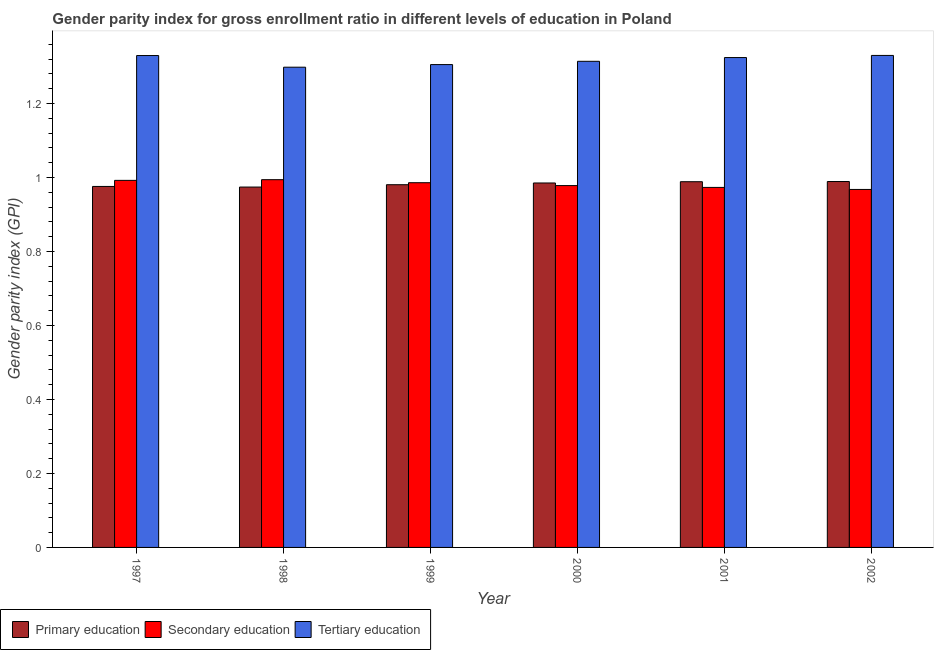Are the number of bars per tick equal to the number of legend labels?
Keep it short and to the point. Yes. Are the number of bars on each tick of the X-axis equal?
Provide a short and direct response. Yes. How many bars are there on the 1st tick from the left?
Provide a succinct answer. 3. What is the label of the 6th group of bars from the left?
Keep it short and to the point. 2002. In how many cases, is the number of bars for a given year not equal to the number of legend labels?
Ensure brevity in your answer.  0. What is the gender parity index in tertiary education in 2000?
Provide a short and direct response. 1.31. Across all years, what is the maximum gender parity index in primary education?
Provide a succinct answer. 0.99. Across all years, what is the minimum gender parity index in primary education?
Your answer should be compact. 0.97. What is the total gender parity index in primary education in the graph?
Ensure brevity in your answer.  5.89. What is the difference between the gender parity index in secondary education in 1997 and that in 2000?
Your answer should be compact. 0.01. What is the difference between the gender parity index in tertiary education in 1999 and the gender parity index in secondary education in 1997?
Offer a terse response. -0.02. What is the average gender parity index in tertiary education per year?
Keep it short and to the point. 1.32. In the year 1999, what is the difference between the gender parity index in tertiary education and gender parity index in primary education?
Your response must be concise. 0. What is the ratio of the gender parity index in secondary education in 1997 to that in 1998?
Offer a very short reply. 1. What is the difference between the highest and the second highest gender parity index in tertiary education?
Offer a terse response. 0. What is the difference between the highest and the lowest gender parity index in primary education?
Keep it short and to the point. 0.01. What does the 3rd bar from the left in 2001 represents?
Provide a short and direct response. Tertiary education. How many bars are there?
Keep it short and to the point. 18. How many years are there in the graph?
Ensure brevity in your answer.  6. Does the graph contain grids?
Provide a succinct answer. No. How are the legend labels stacked?
Your answer should be compact. Horizontal. What is the title of the graph?
Your answer should be very brief. Gender parity index for gross enrollment ratio in different levels of education in Poland. What is the label or title of the X-axis?
Your answer should be very brief. Year. What is the label or title of the Y-axis?
Offer a terse response. Gender parity index (GPI). What is the Gender parity index (GPI) of Primary education in 1997?
Provide a short and direct response. 0.98. What is the Gender parity index (GPI) of Tertiary education in 1997?
Your answer should be very brief. 1.33. What is the Gender parity index (GPI) of Primary education in 1998?
Offer a terse response. 0.97. What is the Gender parity index (GPI) in Secondary education in 1998?
Make the answer very short. 0.99. What is the Gender parity index (GPI) in Tertiary education in 1998?
Make the answer very short. 1.3. What is the Gender parity index (GPI) of Primary education in 1999?
Your response must be concise. 0.98. What is the Gender parity index (GPI) in Secondary education in 1999?
Ensure brevity in your answer.  0.99. What is the Gender parity index (GPI) in Tertiary education in 1999?
Your answer should be very brief. 1.3. What is the Gender parity index (GPI) of Primary education in 2000?
Give a very brief answer. 0.99. What is the Gender parity index (GPI) of Secondary education in 2000?
Give a very brief answer. 0.98. What is the Gender parity index (GPI) of Tertiary education in 2000?
Make the answer very short. 1.31. What is the Gender parity index (GPI) of Primary education in 2001?
Your answer should be compact. 0.99. What is the Gender parity index (GPI) in Secondary education in 2001?
Offer a very short reply. 0.97. What is the Gender parity index (GPI) in Tertiary education in 2001?
Your response must be concise. 1.32. What is the Gender parity index (GPI) of Primary education in 2002?
Provide a succinct answer. 0.99. What is the Gender parity index (GPI) of Secondary education in 2002?
Offer a terse response. 0.97. What is the Gender parity index (GPI) in Tertiary education in 2002?
Offer a terse response. 1.33. Across all years, what is the maximum Gender parity index (GPI) in Primary education?
Your answer should be compact. 0.99. Across all years, what is the maximum Gender parity index (GPI) of Secondary education?
Provide a succinct answer. 0.99. Across all years, what is the maximum Gender parity index (GPI) of Tertiary education?
Your answer should be very brief. 1.33. Across all years, what is the minimum Gender parity index (GPI) of Primary education?
Your answer should be very brief. 0.97. Across all years, what is the minimum Gender parity index (GPI) in Secondary education?
Keep it short and to the point. 0.97. Across all years, what is the minimum Gender parity index (GPI) in Tertiary education?
Your answer should be compact. 1.3. What is the total Gender parity index (GPI) of Primary education in the graph?
Make the answer very short. 5.89. What is the total Gender parity index (GPI) of Secondary education in the graph?
Your answer should be very brief. 5.89. What is the difference between the Gender parity index (GPI) of Primary education in 1997 and that in 1998?
Provide a succinct answer. 0. What is the difference between the Gender parity index (GPI) of Secondary education in 1997 and that in 1998?
Your answer should be very brief. -0. What is the difference between the Gender parity index (GPI) in Tertiary education in 1997 and that in 1998?
Give a very brief answer. 0.03. What is the difference between the Gender parity index (GPI) in Primary education in 1997 and that in 1999?
Ensure brevity in your answer.  -0. What is the difference between the Gender parity index (GPI) in Secondary education in 1997 and that in 1999?
Keep it short and to the point. 0.01. What is the difference between the Gender parity index (GPI) of Tertiary education in 1997 and that in 1999?
Give a very brief answer. 0.02. What is the difference between the Gender parity index (GPI) of Primary education in 1997 and that in 2000?
Offer a very short reply. -0.01. What is the difference between the Gender parity index (GPI) of Secondary education in 1997 and that in 2000?
Give a very brief answer. 0.01. What is the difference between the Gender parity index (GPI) in Tertiary education in 1997 and that in 2000?
Keep it short and to the point. 0.02. What is the difference between the Gender parity index (GPI) of Primary education in 1997 and that in 2001?
Keep it short and to the point. -0.01. What is the difference between the Gender parity index (GPI) of Secondary education in 1997 and that in 2001?
Offer a terse response. 0.02. What is the difference between the Gender parity index (GPI) of Tertiary education in 1997 and that in 2001?
Provide a succinct answer. 0.01. What is the difference between the Gender parity index (GPI) of Primary education in 1997 and that in 2002?
Provide a short and direct response. -0.01. What is the difference between the Gender parity index (GPI) of Secondary education in 1997 and that in 2002?
Your response must be concise. 0.02. What is the difference between the Gender parity index (GPI) of Tertiary education in 1997 and that in 2002?
Provide a short and direct response. -0. What is the difference between the Gender parity index (GPI) of Primary education in 1998 and that in 1999?
Provide a succinct answer. -0.01. What is the difference between the Gender parity index (GPI) of Secondary education in 1998 and that in 1999?
Offer a very short reply. 0.01. What is the difference between the Gender parity index (GPI) in Tertiary education in 1998 and that in 1999?
Offer a terse response. -0.01. What is the difference between the Gender parity index (GPI) in Primary education in 1998 and that in 2000?
Keep it short and to the point. -0.01. What is the difference between the Gender parity index (GPI) in Secondary education in 1998 and that in 2000?
Give a very brief answer. 0.02. What is the difference between the Gender parity index (GPI) in Tertiary education in 1998 and that in 2000?
Offer a terse response. -0.02. What is the difference between the Gender parity index (GPI) of Primary education in 1998 and that in 2001?
Offer a terse response. -0.01. What is the difference between the Gender parity index (GPI) of Secondary education in 1998 and that in 2001?
Your response must be concise. 0.02. What is the difference between the Gender parity index (GPI) in Tertiary education in 1998 and that in 2001?
Make the answer very short. -0.03. What is the difference between the Gender parity index (GPI) in Primary education in 1998 and that in 2002?
Ensure brevity in your answer.  -0.01. What is the difference between the Gender parity index (GPI) in Secondary education in 1998 and that in 2002?
Offer a terse response. 0.03. What is the difference between the Gender parity index (GPI) in Tertiary education in 1998 and that in 2002?
Keep it short and to the point. -0.03. What is the difference between the Gender parity index (GPI) of Primary education in 1999 and that in 2000?
Ensure brevity in your answer.  -0. What is the difference between the Gender parity index (GPI) of Secondary education in 1999 and that in 2000?
Offer a very short reply. 0.01. What is the difference between the Gender parity index (GPI) in Tertiary education in 1999 and that in 2000?
Provide a short and direct response. -0.01. What is the difference between the Gender parity index (GPI) of Primary education in 1999 and that in 2001?
Make the answer very short. -0.01. What is the difference between the Gender parity index (GPI) in Secondary education in 1999 and that in 2001?
Give a very brief answer. 0.01. What is the difference between the Gender parity index (GPI) in Tertiary education in 1999 and that in 2001?
Your answer should be very brief. -0.02. What is the difference between the Gender parity index (GPI) in Primary education in 1999 and that in 2002?
Keep it short and to the point. -0.01. What is the difference between the Gender parity index (GPI) in Secondary education in 1999 and that in 2002?
Keep it short and to the point. 0.02. What is the difference between the Gender parity index (GPI) of Tertiary education in 1999 and that in 2002?
Provide a succinct answer. -0.02. What is the difference between the Gender parity index (GPI) in Primary education in 2000 and that in 2001?
Offer a very short reply. -0. What is the difference between the Gender parity index (GPI) in Secondary education in 2000 and that in 2001?
Offer a very short reply. 0. What is the difference between the Gender parity index (GPI) of Tertiary education in 2000 and that in 2001?
Provide a short and direct response. -0.01. What is the difference between the Gender parity index (GPI) of Primary education in 2000 and that in 2002?
Give a very brief answer. -0. What is the difference between the Gender parity index (GPI) of Secondary education in 2000 and that in 2002?
Your response must be concise. 0.01. What is the difference between the Gender parity index (GPI) in Tertiary education in 2000 and that in 2002?
Ensure brevity in your answer.  -0.02. What is the difference between the Gender parity index (GPI) in Primary education in 2001 and that in 2002?
Keep it short and to the point. -0. What is the difference between the Gender parity index (GPI) in Secondary education in 2001 and that in 2002?
Your answer should be compact. 0.01. What is the difference between the Gender parity index (GPI) of Tertiary education in 2001 and that in 2002?
Your response must be concise. -0.01. What is the difference between the Gender parity index (GPI) of Primary education in 1997 and the Gender parity index (GPI) of Secondary education in 1998?
Give a very brief answer. -0.02. What is the difference between the Gender parity index (GPI) in Primary education in 1997 and the Gender parity index (GPI) in Tertiary education in 1998?
Offer a very short reply. -0.32. What is the difference between the Gender parity index (GPI) of Secondary education in 1997 and the Gender parity index (GPI) of Tertiary education in 1998?
Give a very brief answer. -0.31. What is the difference between the Gender parity index (GPI) in Primary education in 1997 and the Gender parity index (GPI) in Secondary education in 1999?
Provide a succinct answer. -0.01. What is the difference between the Gender parity index (GPI) of Primary education in 1997 and the Gender parity index (GPI) of Tertiary education in 1999?
Your response must be concise. -0.33. What is the difference between the Gender parity index (GPI) in Secondary education in 1997 and the Gender parity index (GPI) in Tertiary education in 1999?
Provide a short and direct response. -0.31. What is the difference between the Gender parity index (GPI) of Primary education in 1997 and the Gender parity index (GPI) of Secondary education in 2000?
Keep it short and to the point. -0. What is the difference between the Gender parity index (GPI) in Primary education in 1997 and the Gender parity index (GPI) in Tertiary education in 2000?
Give a very brief answer. -0.34. What is the difference between the Gender parity index (GPI) of Secondary education in 1997 and the Gender parity index (GPI) of Tertiary education in 2000?
Your answer should be compact. -0.32. What is the difference between the Gender parity index (GPI) in Primary education in 1997 and the Gender parity index (GPI) in Secondary education in 2001?
Offer a very short reply. 0. What is the difference between the Gender parity index (GPI) in Primary education in 1997 and the Gender parity index (GPI) in Tertiary education in 2001?
Ensure brevity in your answer.  -0.35. What is the difference between the Gender parity index (GPI) in Secondary education in 1997 and the Gender parity index (GPI) in Tertiary education in 2001?
Offer a very short reply. -0.33. What is the difference between the Gender parity index (GPI) in Primary education in 1997 and the Gender parity index (GPI) in Secondary education in 2002?
Your response must be concise. 0.01. What is the difference between the Gender parity index (GPI) of Primary education in 1997 and the Gender parity index (GPI) of Tertiary education in 2002?
Keep it short and to the point. -0.35. What is the difference between the Gender parity index (GPI) of Secondary education in 1997 and the Gender parity index (GPI) of Tertiary education in 2002?
Provide a short and direct response. -0.34. What is the difference between the Gender parity index (GPI) of Primary education in 1998 and the Gender parity index (GPI) of Secondary education in 1999?
Offer a terse response. -0.01. What is the difference between the Gender parity index (GPI) of Primary education in 1998 and the Gender parity index (GPI) of Tertiary education in 1999?
Offer a terse response. -0.33. What is the difference between the Gender parity index (GPI) in Secondary education in 1998 and the Gender parity index (GPI) in Tertiary education in 1999?
Make the answer very short. -0.31. What is the difference between the Gender parity index (GPI) in Primary education in 1998 and the Gender parity index (GPI) in Secondary education in 2000?
Offer a very short reply. -0. What is the difference between the Gender parity index (GPI) of Primary education in 1998 and the Gender parity index (GPI) of Tertiary education in 2000?
Your response must be concise. -0.34. What is the difference between the Gender parity index (GPI) in Secondary education in 1998 and the Gender parity index (GPI) in Tertiary education in 2000?
Make the answer very short. -0.32. What is the difference between the Gender parity index (GPI) in Primary education in 1998 and the Gender parity index (GPI) in Secondary education in 2001?
Offer a terse response. 0. What is the difference between the Gender parity index (GPI) in Primary education in 1998 and the Gender parity index (GPI) in Tertiary education in 2001?
Your response must be concise. -0.35. What is the difference between the Gender parity index (GPI) in Secondary education in 1998 and the Gender parity index (GPI) in Tertiary education in 2001?
Provide a succinct answer. -0.33. What is the difference between the Gender parity index (GPI) of Primary education in 1998 and the Gender parity index (GPI) of Secondary education in 2002?
Your answer should be compact. 0.01. What is the difference between the Gender parity index (GPI) of Primary education in 1998 and the Gender parity index (GPI) of Tertiary education in 2002?
Provide a succinct answer. -0.36. What is the difference between the Gender parity index (GPI) of Secondary education in 1998 and the Gender parity index (GPI) of Tertiary education in 2002?
Provide a succinct answer. -0.34. What is the difference between the Gender parity index (GPI) in Primary education in 1999 and the Gender parity index (GPI) in Secondary education in 2000?
Your answer should be compact. 0. What is the difference between the Gender parity index (GPI) in Primary education in 1999 and the Gender parity index (GPI) in Tertiary education in 2000?
Give a very brief answer. -0.33. What is the difference between the Gender parity index (GPI) of Secondary education in 1999 and the Gender parity index (GPI) of Tertiary education in 2000?
Keep it short and to the point. -0.33. What is the difference between the Gender parity index (GPI) in Primary education in 1999 and the Gender parity index (GPI) in Secondary education in 2001?
Give a very brief answer. 0.01. What is the difference between the Gender parity index (GPI) in Primary education in 1999 and the Gender parity index (GPI) in Tertiary education in 2001?
Keep it short and to the point. -0.34. What is the difference between the Gender parity index (GPI) of Secondary education in 1999 and the Gender parity index (GPI) of Tertiary education in 2001?
Your response must be concise. -0.34. What is the difference between the Gender parity index (GPI) in Primary education in 1999 and the Gender parity index (GPI) in Secondary education in 2002?
Offer a terse response. 0.01. What is the difference between the Gender parity index (GPI) in Primary education in 1999 and the Gender parity index (GPI) in Tertiary education in 2002?
Ensure brevity in your answer.  -0.35. What is the difference between the Gender parity index (GPI) in Secondary education in 1999 and the Gender parity index (GPI) in Tertiary education in 2002?
Your answer should be very brief. -0.34. What is the difference between the Gender parity index (GPI) in Primary education in 2000 and the Gender parity index (GPI) in Secondary education in 2001?
Your answer should be compact. 0.01. What is the difference between the Gender parity index (GPI) of Primary education in 2000 and the Gender parity index (GPI) of Tertiary education in 2001?
Offer a terse response. -0.34. What is the difference between the Gender parity index (GPI) in Secondary education in 2000 and the Gender parity index (GPI) in Tertiary education in 2001?
Provide a short and direct response. -0.35. What is the difference between the Gender parity index (GPI) of Primary education in 2000 and the Gender parity index (GPI) of Secondary education in 2002?
Make the answer very short. 0.02. What is the difference between the Gender parity index (GPI) of Primary education in 2000 and the Gender parity index (GPI) of Tertiary education in 2002?
Provide a short and direct response. -0.34. What is the difference between the Gender parity index (GPI) in Secondary education in 2000 and the Gender parity index (GPI) in Tertiary education in 2002?
Your answer should be very brief. -0.35. What is the difference between the Gender parity index (GPI) of Primary education in 2001 and the Gender parity index (GPI) of Secondary education in 2002?
Provide a short and direct response. 0.02. What is the difference between the Gender parity index (GPI) of Primary education in 2001 and the Gender parity index (GPI) of Tertiary education in 2002?
Give a very brief answer. -0.34. What is the difference between the Gender parity index (GPI) in Secondary education in 2001 and the Gender parity index (GPI) in Tertiary education in 2002?
Give a very brief answer. -0.36. What is the average Gender parity index (GPI) in Primary education per year?
Your response must be concise. 0.98. What is the average Gender parity index (GPI) of Secondary education per year?
Give a very brief answer. 0.98. What is the average Gender parity index (GPI) in Tertiary education per year?
Your response must be concise. 1.32. In the year 1997, what is the difference between the Gender parity index (GPI) of Primary education and Gender parity index (GPI) of Secondary education?
Keep it short and to the point. -0.02. In the year 1997, what is the difference between the Gender parity index (GPI) of Primary education and Gender parity index (GPI) of Tertiary education?
Keep it short and to the point. -0.35. In the year 1997, what is the difference between the Gender parity index (GPI) of Secondary education and Gender parity index (GPI) of Tertiary education?
Provide a succinct answer. -0.34. In the year 1998, what is the difference between the Gender parity index (GPI) of Primary education and Gender parity index (GPI) of Secondary education?
Give a very brief answer. -0.02. In the year 1998, what is the difference between the Gender parity index (GPI) of Primary education and Gender parity index (GPI) of Tertiary education?
Make the answer very short. -0.32. In the year 1998, what is the difference between the Gender parity index (GPI) of Secondary education and Gender parity index (GPI) of Tertiary education?
Provide a short and direct response. -0.3. In the year 1999, what is the difference between the Gender parity index (GPI) in Primary education and Gender parity index (GPI) in Secondary education?
Ensure brevity in your answer.  -0.01. In the year 1999, what is the difference between the Gender parity index (GPI) in Primary education and Gender parity index (GPI) in Tertiary education?
Ensure brevity in your answer.  -0.32. In the year 1999, what is the difference between the Gender parity index (GPI) of Secondary education and Gender parity index (GPI) of Tertiary education?
Provide a short and direct response. -0.32. In the year 2000, what is the difference between the Gender parity index (GPI) of Primary education and Gender parity index (GPI) of Secondary education?
Your answer should be compact. 0.01. In the year 2000, what is the difference between the Gender parity index (GPI) in Primary education and Gender parity index (GPI) in Tertiary education?
Provide a succinct answer. -0.33. In the year 2000, what is the difference between the Gender parity index (GPI) of Secondary education and Gender parity index (GPI) of Tertiary education?
Provide a short and direct response. -0.34. In the year 2001, what is the difference between the Gender parity index (GPI) in Primary education and Gender parity index (GPI) in Secondary education?
Offer a terse response. 0.02. In the year 2001, what is the difference between the Gender parity index (GPI) in Primary education and Gender parity index (GPI) in Tertiary education?
Give a very brief answer. -0.34. In the year 2001, what is the difference between the Gender parity index (GPI) in Secondary education and Gender parity index (GPI) in Tertiary education?
Ensure brevity in your answer.  -0.35. In the year 2002, what is the difference between the Gender parity index (GPI) of Primary education and Gender parity index (GPI) of Secondary education?
Make the answer very short. 0.02. In the year 2002, what is the difference between the Gender parity index (GPI) in Primary education and Gender parity index (GPI) in Tertiary education?
Offer a very short reply. -0.34. In the year 2002, what is the difference between the Gender parity index (GPI) in Secondary education and Gender parity index (GPI) in Tertiary education?
Provide a short and direct response. -0.36. What is the ratio of the Gender parity index (GPI) of Primary education in 1997 to that in 1998?
Ensure brevity in your answer.  1. What is the ratio of the Gender parity index (GPI) in Tertiary education in 1997 to that in 1998?
Provide a short and direct response. 1.02. What is the ratio of the Gender parity index (GPI) of Primary education in 1997 to that in 1999?
Offer a terse response. 1. What is the ratio of the Gender parity index (GPI) of Secondary education in 1997 to that in 1999?
Provide a short and direct response. 1.01. What is the ratio of the Gender parity index (GPI) in Tertiary education in 1997 to that in 1999?
Offer a terse response. 1.02. What is the ratio of the Gender parity index (GPI) in Secondary education in 1997 to that in 2000?
Provide a short and direct response. 1.01. What is the ratio of the Gender parity index (GPI) of Tertiary education in 1997 to that in 2000?
Your answer should be very brief. 1.01. What is the ratio of the Gender parity index (GPI) of Primary education in 1997 to that in 2001?
Offer a very short reply. 0.99. What is the ratio of the Gender parity index (GPI) of Secondary education in 1997 to that in 2001?
Offer a terse response. 1.02. What is the ratio of the Gender parity index (GPI) of Primary education in 1997 to that in 2002?
Your answer should be very brief. 0.99. What is the ratio of the Gender parity index (GPI) in Secondary education in 1997 to that in 2002?
Make the answer very short. 1.03. What is the ratio of the Gender parity index (GPI) in Secondary education in 1998 to that in 1999?
Offer a terse response. 1.01. What is the ratio of the Gender parity index (GPI) in Tertiary education in 1998 to that in 1999?
Offer a very short reply. 0.99. What is the ratio of the Gender parity index (GPI) in Secondary education in 1998 to that in 2000?
Provide a short and direct response. 1.02. What is the ratio of the Gender parity index (GPI) of Tertiary education in 1998 to that in 2000?
Offer a terse response. 0.99. What is the ratio of the Gender parity index (GPI) in Primary education in 1998 to that in 2001?
Your response must be concise. 0.99. What is the ratio of the Gender parity index (GPI) of Secondary education in 1998 to that in 2001?
Your response must be concise. 1.02. What is the ratio of the Gender parity index (GPI) in Tertiary education in 1998 to that in 2001?
Provide a succinct answer. 0.98. What is the ratio of the Gender parity index (GPI) in Primary education in 1998 to that in 2002?
Ensure brevity in your answer.  0.98. What is the ratio of the Gender parity index (GPI) in Secondary education in 1998 to that in 2002?
Give a very brief answer. 1.03. What is the ratio of the Gender parity index (GPI) in Tertiary education in 1998 to that in 2002?
Your answer should be compact. 0.98. What is the ratio of the Gender parity index (GPI) of Tertiary education in 1999 to that in 2000?
Give a very brief answer. 0.99. What is the ratio of the Gender parity index (GPI) of Primary education in 1999 to that in 2001?
Your answer should be compact. 0.99. What is the ratio of the Gender parity index (GPI) of Tertiary education in 1999 to that in 2001?
Your answer should be very brief. 0.99. What is the ratio of the Gender parity index (GPI) of Secondary education in 1999 to that in 2002?
Provide a short and direct response. 1.02. What is the ratio of the Gender parity index (GPI) of Tertiary education in 1999 to that in 2002?
Your answer should be compact. 0.98. What is the ratio of the Gender parity index (GPI) in Tertiary education in 2000 to that in 2001?
Ensure brevity in your answer.  0.99. What is the ratio of the Gender parity index (GPI) in Primary education in 2000 to that in 2002?
Offer a very short reply. 1. What is the ratio of the Gender parity index (GPI) of Secondary education in 2000 to that in 2002?
Keep it short and to the point. 1.01. What is the ratio of the Gender parity index (GPI) of Tertiary education in 2000 to that in 2002?
Your response must be concise. 0.99. What is the ratio of the Gender parity index (GPI) of Secondary education in 2001 to that in 2002?
Your answer should be very brief. 1.01. What is the ratio of the Gender parity index (GPI) in Tertiary education in 2001 to that in 2002?
Offer a very short reply. 1. What is the difference between the highest and the second highest Gender parity index (GPI) in Primary education?
Ensure brevity in your answer.  0. What is the difference between the highest and the second highest Gender parity index (GPI) of Secondary education?
Your answer should be very brief. 0. What is the difference between the highest and the lowest Gender parity index (GPI) in Primary education?
Keep it short and to the point. 0.01. What is the difference between the highest and the lowest Gender parity index (GPI) in Secondary education?
Keep it short and to the point. 0.03. What is the difference between the highest and the lowest Gender parity index (GPI) of Tertiary education?
Offer a terse response. 0.03. 